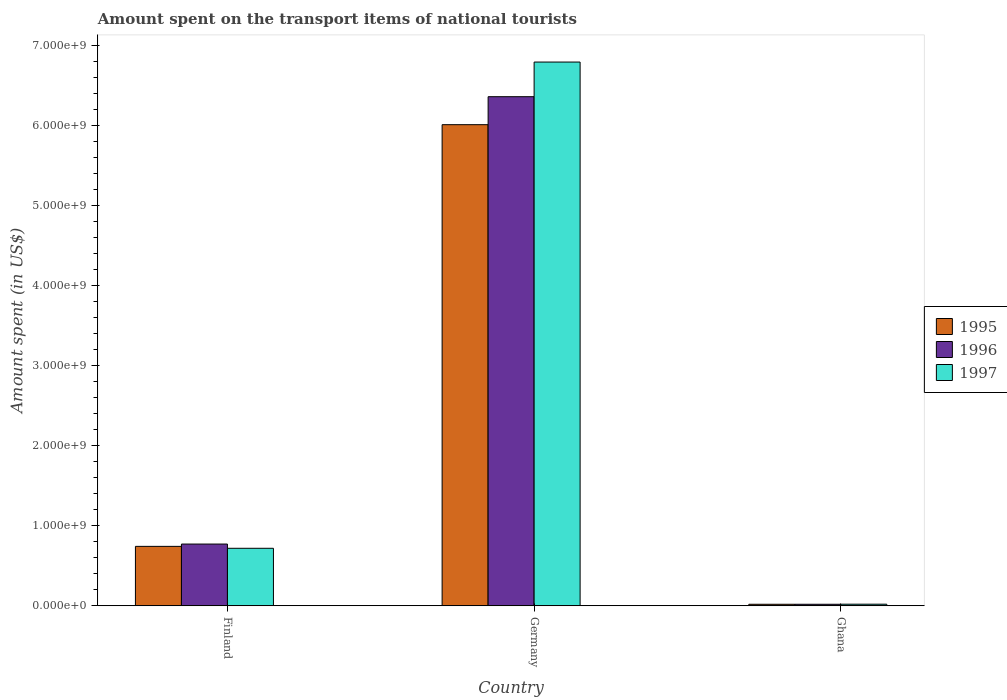How many bars are there on the 3rd tick from the left?
Make the answer very short. 3. Across all countries, what is the maximum amount spent on the transport items of national tourists in 1995?
Ensure brevity in your answer.  6.02e+09. In which country was the amount spent on the transport items of national tourists in 1997 maximum?
Ensure brevity in your answer.  Germany. What is the total amount spent on the transport items of national tourists in 1995 in the graph?
Ensure brevity in your answer.  6.78e+09. What is the difference between the amount spent on the transport items of national tourists in 1996 in Finland and that in Germany?
Make the answer very short. -5.59e+09. What is the difference between the amount spent on the transport items of national tourists in 1995 in Ghana and the amount spent on the transport items of national tourists in 1997 in Finland?
Keep it short and to the point. -7.00e+08. What is the average amount spent on the transport items of national tourists in 1996 per country?
Provide a succinct answer. 2.39e+09. What is the difference between the amount spent on the transport items of national tourists of/in 1995 and amount spent on the transport items of national tourists of/in 1997 in Finland?
Ensure brevity in your answer.  2.40e+07. In how many countries, is the amount spent on the transport items of national tourists in 1997 greater than 6000000000 US$?
Offer a very short reply. 1. What is the ratio of the amount spent on the transport items of national tourists in 1997 in Finland to that in Germany?
Your response must be concise. 0.11. Is the amount spent on the transport items of national tourists in 1997 in Germany less than that in Ghana?
Offer a terse response. No. Is the difference between the amount spent on the transport items of national tourists in 1995 in Germany and Ghana greater than the difference between the amount spent on the transport items of national tourists in 1997 in Germany and Ghana?
Ensure brevity in your answer.  No. What is the difference between the highest and the second highest amount spent on the transport items of national tourists in 1995?
Keep it short and to the point. 6.00e+09. What is the difference between the highest and the lowest amount spent on the transport items of national tourists in 1995?
Offer a terse response. 6.00e+09. Is the sum of the amount spent on the transport items of national tourists in 1995 in Finland and Ghana greater than the maximum amount spent on the transport items of national tourists in 1996 across all countries?
Keep it short and to the point. No. Are all the bars in the graph horizontal?
Make the answer very short. No. How many countries are there in the graph?
Provide a succinct answer. 3. What is the difference between two consecutive major ticks on the Y-axis?
Make the answer very short. 1.00e+09. Are the values on the major ticks of Y-axis written in scientific E-notation?
Keep it short and to the point. Yes. Does the graph contain grids?
Give a very brief answer. No. Where does the legend appear in the graph?
Keep it short and to the point. Center right. What is the title of the graph?
Your response must be concise. Amount spent on the transport items of national tourists. What is the label or title of the Y-axis?
Provide a short and direct response. Amount spent (in US$). What is the Amount spent (in US$) of 1995 in Finland?
Ensure brevity in your answer.  7.43e+08. What is the Amount spent (in US$) in 1996 in Finland?
Ensure brevity in your answer.  7.72e+08. What is the Amount spent (in US$) in 1997 in Finland?
Offer a terse response. 7.19e+08. What is the Amount spent (in US$) of 1995 in Germany?
Your answer should be very brief. 6.02e+09. What is the Amount spent (in US$) in 1996 in Germany?
Offer a terse response. 6.37e+09. What is the Amount spent (in US$) of 1997 in Germany?
Your answer should be very brief. 6.80e+09. What is the Amount spent (in US$) of 1995 in Ghana?
Ensure brevity in your answer.  1.90e+07. What is the Amount spent (in US$) in 1996 in Ghana?
Provide a succinct answer. 1.90e+07. What is the Amount spent (in US$) of 1997 in Ghana?
Offer a terse response. 2.00e+07. Across all countries, what is the maximum Amount spent (in US$) of 1995?
Your answer should be compact. 6.02e+09. Across all countries, what is the maximum Amount spent (in US$) of 1996?
Offer a terse response. 6.37e+09. Across all countries, what is the maximum Amount spent (in US$) of 1997?
Provide a succinct answer. 6.80e+09. Across all countries, what is the minimum Amount spent (in US$) of 1995?
Make the answer very short. 1.90e+07. Across all countries, what is the minimum Amount spent (in US$) of 1996?
Your answer should be compact. 1.90e+07. What is the total Amount spent (in US$) of 1995 in the graph?
Offer a terse response. 6.78e+09. What is the total Amount spent (in US$) in 1996 in the graph?
Provide a succinct answer. 7.16e+09. What is the total Amount spent (in US$) in 1997 in the graph?
Your response must be concise. 7.54e+09. What is the difference between the Amount spent (in US$) in 1995 in Finland and that in Germany?
Offer a very short reply. -5.27e+09. What is the difference between the Amount spent (in US$) in 1996 in Finland and that in Germany?
Offer a terse response. -5.59e+09. What is the difference between the Amount spent (in US$) in 1997 in Finland and that in Germany?
Keep it short and to the point. -6.08e+09. What is the difference between the Amount spent (in US$) of 1995 in Finland and that in Ghana?
Your response must be concise. 7.24e+08. What is the difference between the Amount spent (in US$) of 1996 in Finland and that in Ghana?
Offer a very short reply. 7.53e+08. What is the difference between the Amount spent (in US$) of 1997 in Finland and that in Ghana?
Your answer should be very brief. 6.99e+08. What is the difference between the Amount spent (in US$) in 1995 in Germany and that in Ghana?
Provide a short and direct response. 6.00e+09. What is the difference between the Amount spent (in US$) of 1996 in Germany and that in Ghana?
Your response must be concise. 6.35e+09. What is the difference between the Amount spent (in US$) of 1997 in Germany and that in Ghana?
Your answer should be very brief. 6.78e+09. What is the difference between the Amount spent (in US$) in 1995 in Finland and the Amount spent (in US$) in 1996 in Germany?
Offer a terse response. -5.62e+09. What is the difference between the Amount spent (in US$) of 1995 in Finland and the Amount spent (in US$) of 1997 in Germany?
Offer a terse response. -6.06e+09. What is the difference between the Amount spent (in US$) in 1996 in Finland and the Amount spent (in US$) in 1997 in Germany?
Make the answer very short. -6.03e+09. What is the difference between the Amount spent (in US$) in 1995 in Finland and the Amount spent (in US$) in 1996 in Ghana?
Offer a very short reply. 7.24e+08. What is the difference between the Amount spent (in US$) of 1995 in Finland and the Amount spent (in US$) of 1997 in Ghana?
Keep it short and to the point. 7.23e+08. What is the difference between the Amount spent (in US$) of 1996 in Finland and the Amount spent (in US$) of 1997 in Ghana?
Your answer should be compact. 7.52e+08. What is the difference between the Amount spent (in US$) of 1995 in Germany and the Amount spent (in US$) of 1996 in Ghana?
Provide a short and direct response. 6.00e+09. What is the difference between the Amount spent (in US$) in 1995 in Germany and the Amount spent (in US$) in 1997 in Ghana?
Your response must be concise. 6.00e+09. What is the difference between the Amount spent (in US$) of 1996 in Germany and the Amount spent (in US$) of 1997 in Ghana?
Provide a short and direct response. 6.35e+09. What is the average Amount spent (in US$) in 1995 per country?
Give a very brief answer. 2.26e+09. What is the average Amount spent (in US$) in 1996 per country?
Make the answer very short. 2.39e+09. What is the average Amount spent (in US$) of 1997 per country?
Your answer should be compact. 2.51e+09. What is the difference between the Amount spent (in US$) of 1995 and Amount spent (in US$) of 1996 in Finland?
Make the answer very short. -2.90e+07. What is the difference between the Amount spent (in US$) of 1995 and Amount spent (in US$) of 1997 in Finland?
Make the answer very short. 2.40e+07. What is the difference between the Amount spent (in US$) in 1996 and Amount spent (in US$) in 1997 in Finland?
Ensure brevity in your answer.  5.30e+07. What is the difference between the Amount spent (in US$) in 1995 and Amount spent (in US$) in 1996 in Germany?
Keep it short and to the point. -3.50e+08. What is the difference between the Amount spent (in US$) in 1995 and Amount spent (in US$) in 1997 in Germany?
Your answer should be compact. -7.83e+08. What is the difference between the Amount spent (in US$) in 1996 and Amount spent (in US$) in 1997 in Germany?
Your response must be concise. -4.33e+08. What is the ratio of the Amount spent (in US$) in 1995 in Finland to that in Germany?
Give a very brief answer. 0.12. What is the ratio of the Amount spent (in US$) in 1996 in Finland to that in Germany?
Give a very brief answer. 0.12. What is the ratio of the Amount spent (in US$) of 1997 in Finland to that in Germany?
Offer a terse response. 0.11. What is the ratio of the Amount spent (in US$) in 1995 in Finland to that in Ghana?
Give a very brief answer. 39.11. What is the ratio of the Amount spent (in US$) of 1996 in Finland to that in Ghana?
Give a very brief answer. 40.63. What is the ratio of the Amount spent (in US$) of 1997 in Finland to that in Ghana?
Your response must be concise. 35.95. What is the ratio of the Amount spent (in US$) in 1995 in Germany to that in Ghana?
Make the answer very short. 316.63. What is the ratio of the Amount spent (in US$) in 1996 in Germany to that in Ghana?
Provide a short and direct response. 335.05. What is the ratio of the Amount spent (in US$) in 1997 in Germany to that in Ghana?
Make the answer very short. 339.95. What is the difference between the highest and the second highest Amount spent (in US$) in 1995?
Provide a short and direct response. 5.27e+09. What is the difference between the highest and the second highest Amount spent (in US$) in 1996?
Ensure brevity in your answer.  5.59e+09. What is the difference between the highest and the second highest Amount spent (in US$) in 1997?
Provide a succinct answer. 6.08e+09. What is the difference between the highest and the lowest Amount spent (in US$) of 1995?
Provide a short and direct response. 6.00e+09. What is the difference between the highest and the lowest Amount spent (in US$) of 1996?
Make the answer very short. 6.35e+09. What is the difference between the highest and the lowest Amount spent (in US$) in 1997?
Keep it short and to the point. 6.78e+09. 